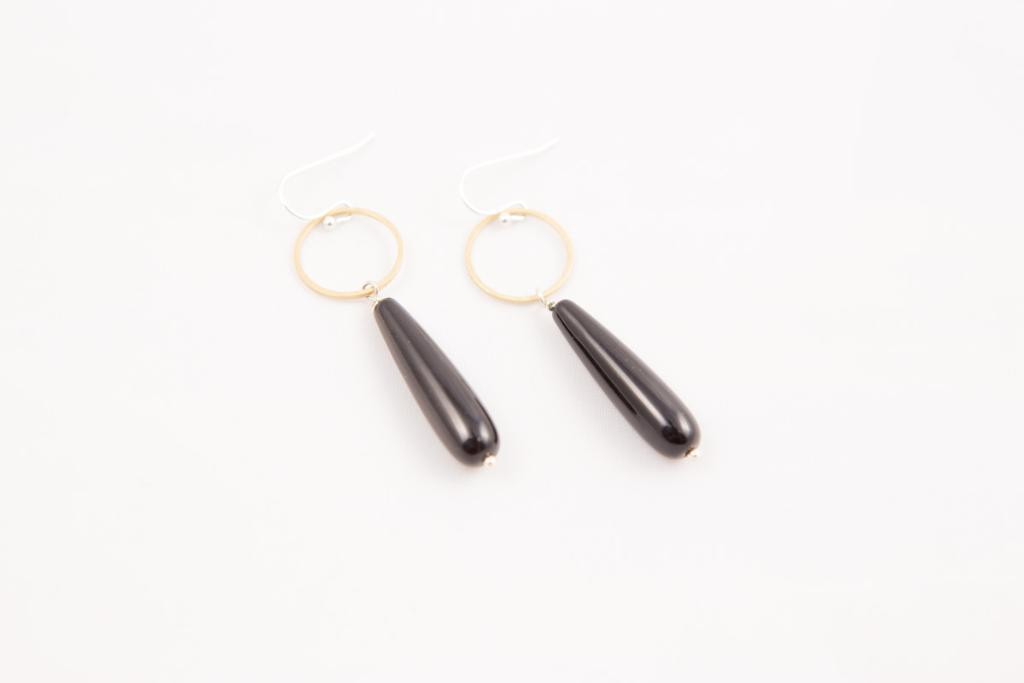What is the main subject of the image? The main subject of the image is a pair of earrings. What colors are the earrings in the image? The earrings are in golden and black color. What type of stone can be seen in the center of the image? There is no stone present in the image; it features a pair of earrings in golden and black color. How many bubbles are visible around the earrings in the image? There are no bubbles present in the image; it only features a pair of earrings. 